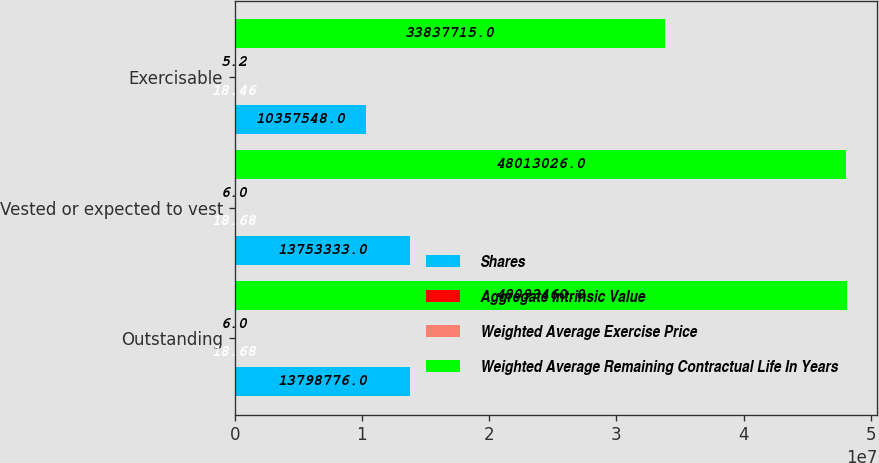Convert chart to OTSL. <chart><loc_0><loc_0><loc_500><loc_500><stacked_bar_chart><ecel><fcel>Outstanding<fcel>Vested or expected to vest<fcel>Exercisable<nl><fcel>Shares<fcel>1.37988e+07<fcel>1.37533e+07<fcel>1.03575e+07<nl><fcel>Aggregate Intrinsic Value<fcel>18.68<fcel>18.68<fcel>18.46<nl><fcel>Weighted Average Exercise Price<fcel>6<fcel>6<fcel>5.2<nl><fcel>Weighted Average Remaining Contractual Life In Years<fcel>4.80935e+07<fcel>4.8013e+07<fcel>3.38377e+07<nl></chart> 